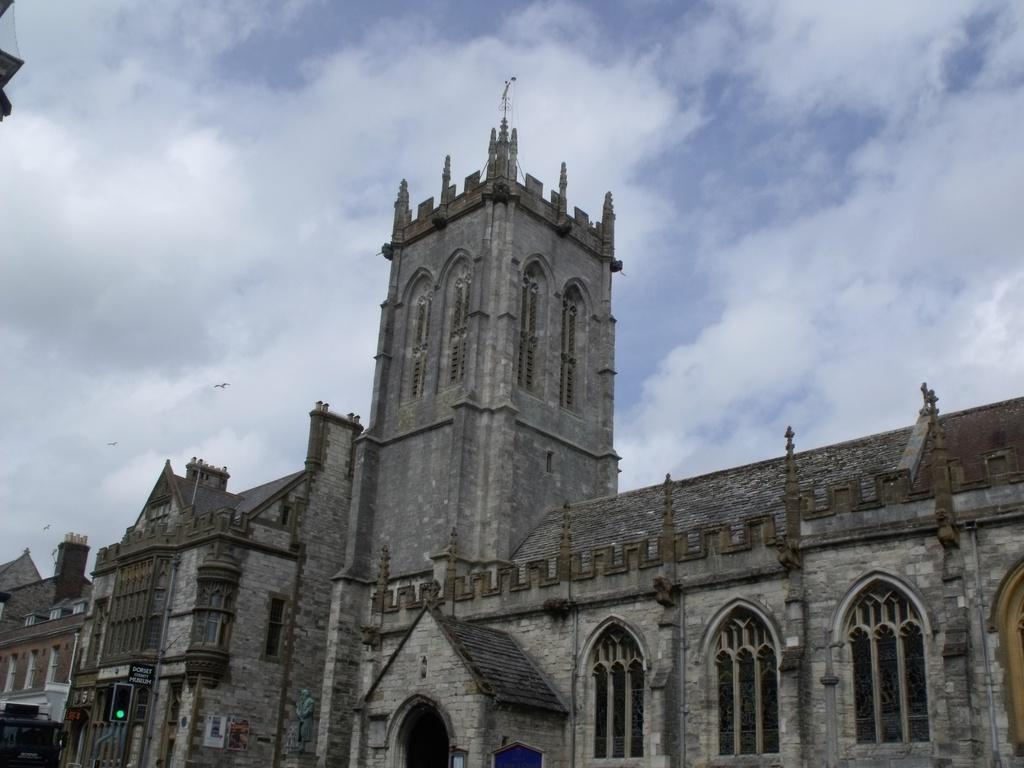What type of structure is visible in the picture? There is a building in the picture. What is the condition of the sky in the picture? The sky is cloudy in the picture. What type of circle can be seen in the picture? There is no circle present in the picture. What language is spoken by the people in the picture? The picture does not depict any people, so it is impossible to determine the language spoken. 